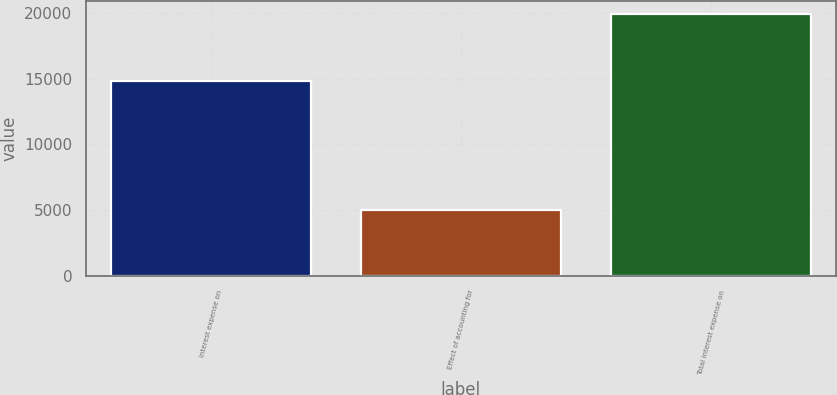Convert chart. <chart><loc_0><loc_0><loc_500><loc_500><bar_chart><fcel>Interest expense on<fcel>Effect of accounting for<fcel>Total interest expense on<nl><fcel>14850<fcel>5024<fcel>19874<nl></chart> 